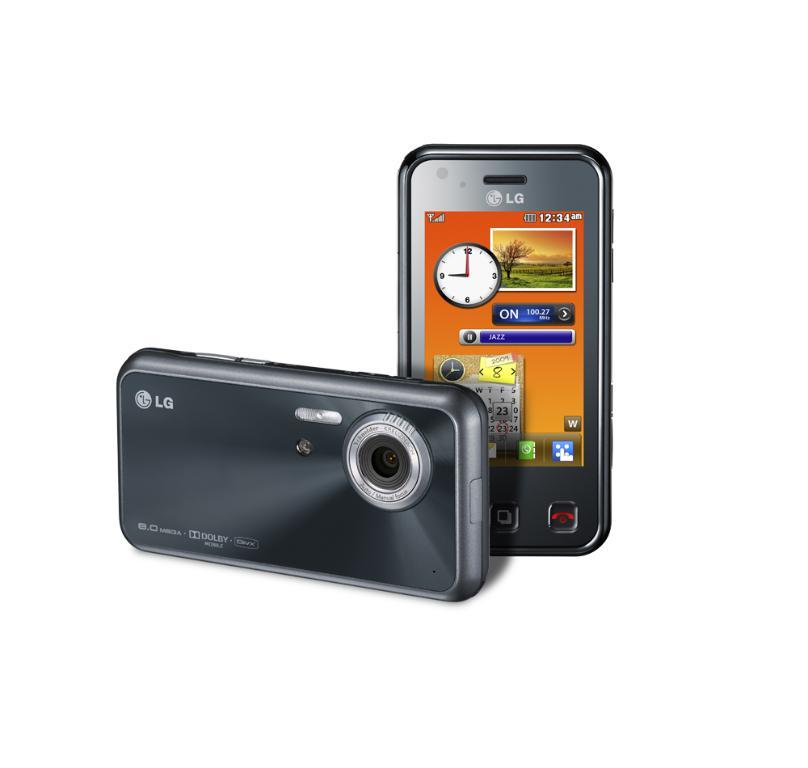<image>
Summarize the visual content of the image. An LG phone is displayed on a white background. 